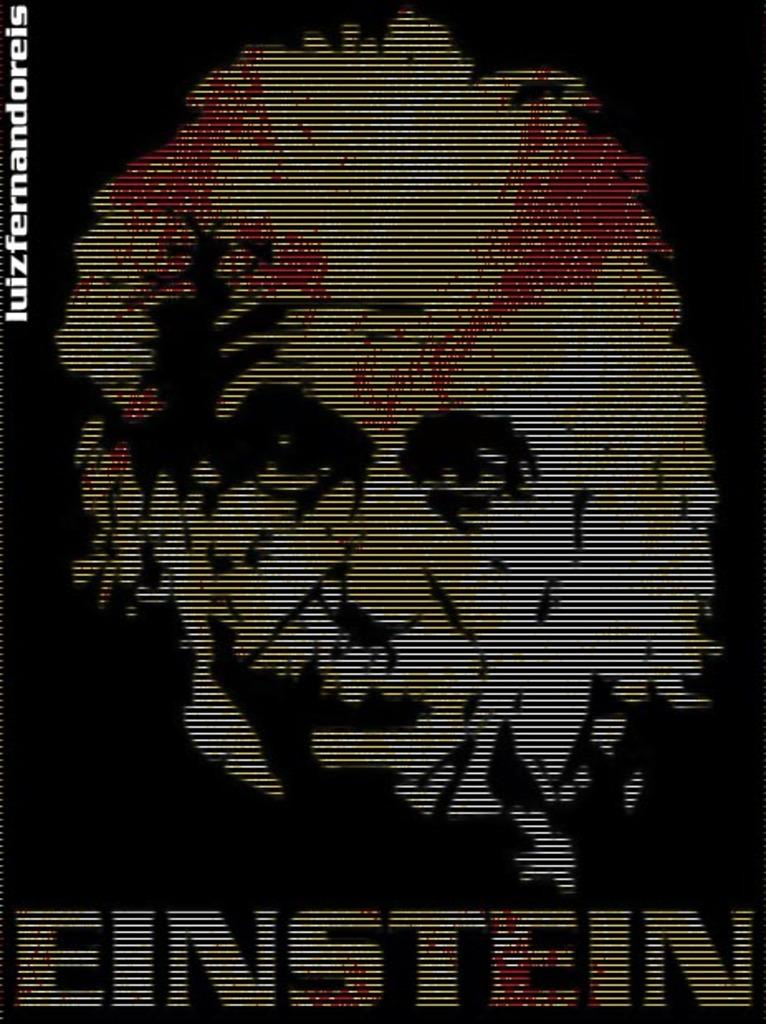<image>
Summarize the visual content of the image. A scanlined image of Albert Einstein with the name Einstein written at the bottom. 